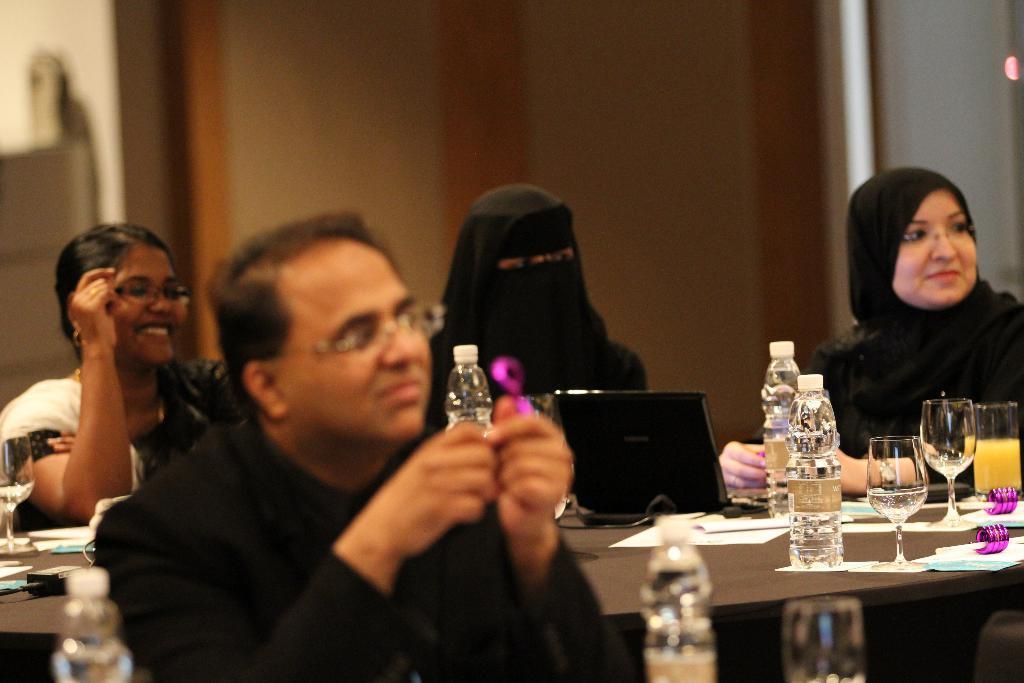Could you give a brief overview of what you see in this image? people are sitting on the chairs around the table. on the table there is a laptop, bottle, glass. the person at the front is wearing a black dress. 3 women are seated at the back. the person at the center covered her face. 